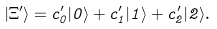Convert formula to latex. <formula><loc_0><loc_0><loc_500><loc_500>| \Xi ^ { \prime } \rangle = c _ { 0 } ^ { \prime } | 0 \rangle + c _ { 1 } ^ { \prime } | 1 \rangle + c _ { 2 } ^ { \prime } | 2 \rangle .</formula> 